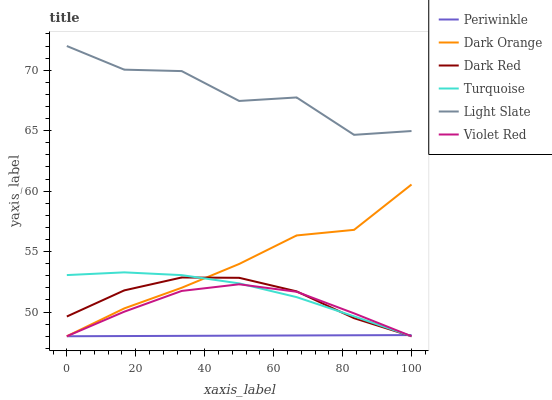Does Periwinkle have the minimum area under the curve?
Answer yes or no. Yes. Does Light Slate have the maximum area under the curve?
Answer yes or no. Yes. Does Turquoise have the minimum area under the curve?
Answer yes or no. No. Does Turquoise have the maximum area under the curve?
Answer yes or no. No. Is Periwinkle the smoothest?
Answer yes or no. Yes. Is Light Slate the roughest?
Answer yes or no. Yes. Is Turquoise the smoothest?
Answer yes or no. No. Is Turquoise the roughest?
Answer yes or no. No. Does Light Slate have the lowest value?
Answer yes or no. No. Does Light Slate have the highest value?
Answer yes or no. Yes. Does Turquoise have the highest value?
Answer yes or no. No. Is Violet Red less than Light Slate?
Answer yes or no. Yes. Is Light Slate greater than Dark Orange?
Answer yes or no. Yes. Does Dark Orange intersect Violet Red?
Answer yes or no. Yes. Is Dark Orange less than Violet Red?
Answer yes or no. No. Is Dark Orange greater than Violet Red?
Answer yes or no. No. Does Violet Red intersect Light Slate?
Answer yes or no. No. 